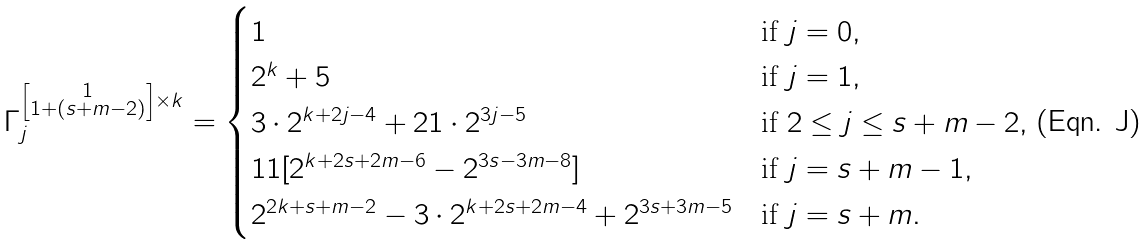<formula> <loc_0><loc_0><loc_500><loc_500>\Gamma _ { j } ^ { \left [ \substack { 1 \\ 1 + ( s + m - 2 ) } \right ] \times k } = \begin{cases} 1 & \text {if } j = 0 , \\ 2 ^ { k } + 5 & \text {if } j = 1 , \\ 3 \cdot 2 ^ { k + 2 j - 4 } + 2 1 \cdot 2 ^ { 3 j - 5 } & \text {if  } 2 \leq j \leq s + m - 2 , \\ 1 1 [ 2 ^ { k + 2 s + 2 m - 6 } - 2 ^ { 3 s - 3 m - 8 } ] & \text {if  } j = s + m - 1 , \\ 2 ^ { 2 k + s + m - 2 } - 3 \cdot 2 ^ { k + 2 s + 2 m - 4 } + 2 ^ { 3 s + 3 m - 5 } & \text {if  } j = s + m . \end{cases}</formula> 